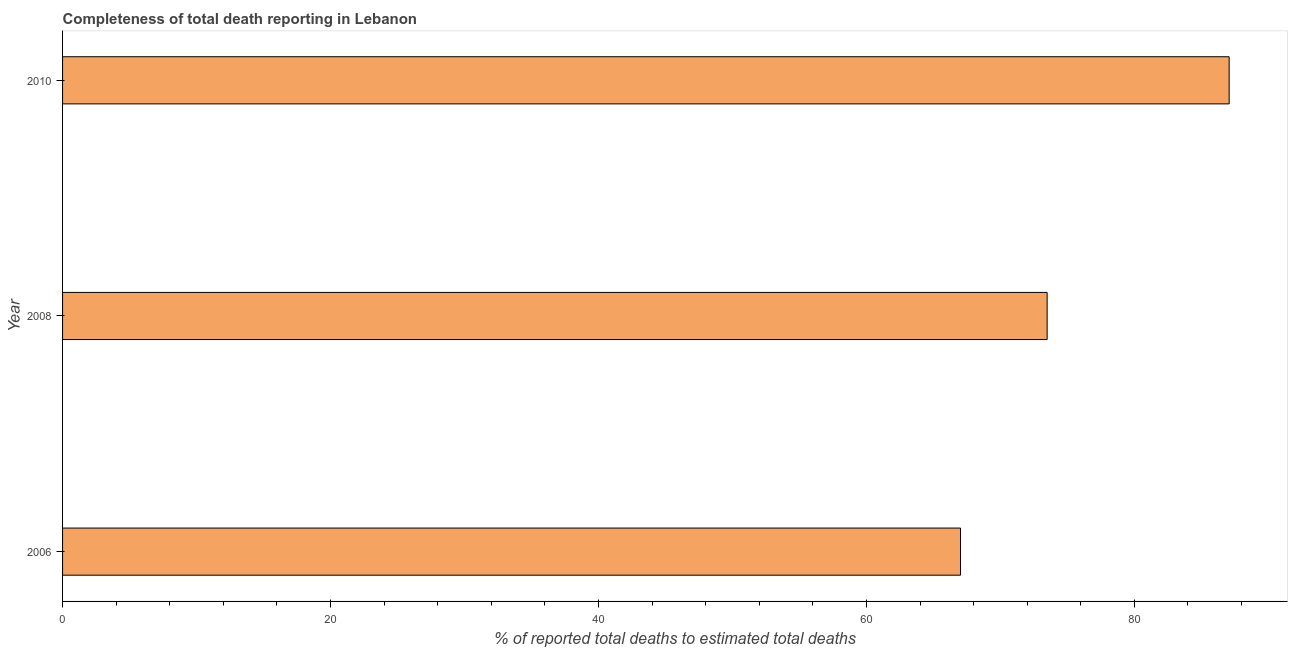Does the graph contain any zero values?
Your response must be concise. No. What is the title of the graph?
Provide a short and direct response. Completeness of total death reporting in Lebanon. What is the label or title of the X-axis?
Provide a short and direct response. % of reported total deaths to estimated total deaths. What is the completeness of total death reports in 2008?
Your answer should be very brief. 73.49. Across all years, what is the maximum completeness of total death reports?
Give a very brief answer. 87.08. Across all years, what is the minimum completeness of total death reports?
Make the answer very short. 67.02. In which year was the completeness of total death reports minimum?
Keep it short and to the point. 2006. What is the sum of the completeness of total death reports?
Give a very brief answer. 227.59. What is the difference between the completeness of total death reports in 2006 and 2008?
Ensure brevity in your answer.  -6.46. What is the average completeness of total death reports per year?
Keep it short and to the point. 75.86. What is the median completeness of total death reports?
Provide a short and direct response. 73.49. In how many years, is the completeness of total death reports greater than 84 %?
Your answer should be compact. 1. What is the ratio of the completeness of total death reports in 2008 to that in 2010?
Give a very brief answer. 0.84. Is the completeness of total death reports in 2006 less than that in 2010?
Provide a short and direct response. Yes. What is the difference between the highest and the second highest completeness of total death reports?
Offer a terse response. 13.59. Is the sum of the completeness of total death reports in 2006 and 2008 greater than the maximum completeness of total death reports across all years?
Keep it short and to the point. Yes. What is the difference between the highest and the lowest completeness of total death reports?
Give a very brief answer. 20.05. How many bars are there?
Give a very brief answer. 3. How many years are there in the graph?
Provide a succinct answer. 3. What is the % of reported total deaths to estimated total deaths of 2006?
Your response must be concise. 67.02. What is the % of reported total deaths to estimated total deaths in 2008?
Make the answer very short. 73.49. What is the % of reported total deaths to estimated total deaths in 2010?
Make the answer very short. 87.08. What is the difference between the % of reported total deaths to estimated total deaths in 2006 and 2008?
Give a very brief answer. -6.46. What is the difference between the % of reported total deaths to estimated total deaths in 2006 and 2010?
Make the answer very short. -20.05. What is the difference between the % of reported total deaths to estimated total deaths in 2008 and 2010?
Give a very brief answer. -13.59. What is the ratio of the % of reported total deaths to estimated total deaths in 2006 to that in 2008?
Keep it short and to the point. 0.91. What is the ratio of the % of reported total deaths to estimated total deaths in 2006 to that in 2010?
Offer a very short reply. 0.77. What is the ratio of the % of reported total deaths to estimated total deaths in 2008 to that in 2010?
Provide a succinct answer. 0.84. 